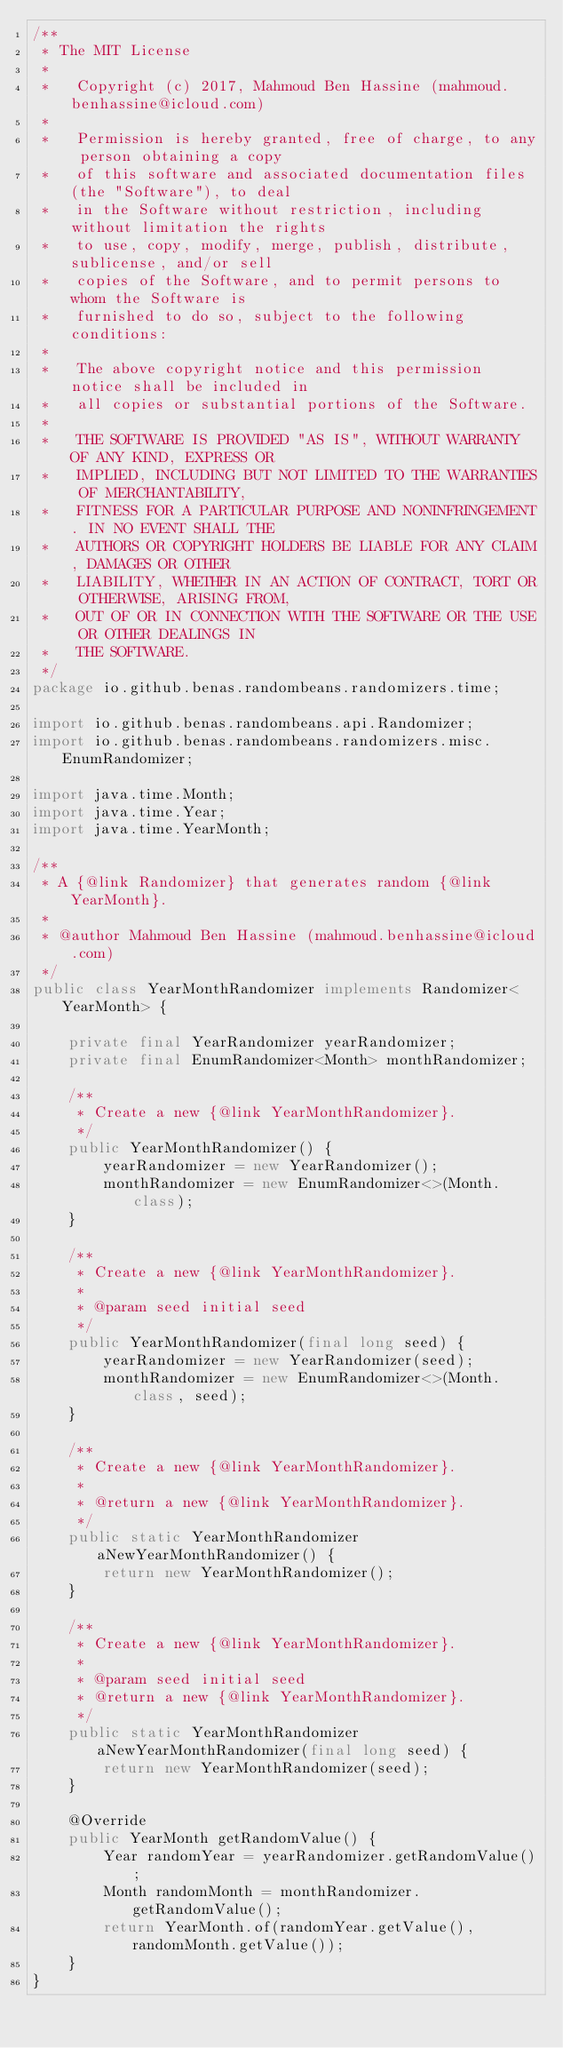Convert code to text. <code><loc_0><loc_0><loc_500><loc_500><_Java_>/**
 * The MIT License
 *
 *   Copyright (c) 2017, Mahmoud Ben Hassine (mahmoud.benhassine@icloud.com)
 *
 *   Permission is hereby granted, free of charge, to any person obtaining a copy
 *   of this software and associated documentation files (the "Software"), to deal
 *   in the Software without restriction, including without limitation the rights
 *   to use, copy, modify, merge, publish, distribute, sublicense, and/or sell
 *   copies of the Software, and to permit persons to whom the Software is
 *   furnished to do so, subject to the following conditions:
 *
 *   The above copyright notice and this permission notice shall be included in
 *   all copies or substantial portions of the Software.
 *
 *   THE SOFTWARE IS PROVIDED "AS IS", WITHOUT WARRANTY OF ANY KIND, EXPRESS OR
 *   IMPLIED, INCLUDING BUT NOT LIMITED TO THE WARRANTIES OF MERCHANTABILITY,
 *   FITNESS FOR A PARTICULAR PURPOSE AND NONINFRINGEMENT. IN NO EVENT SHALL THE
 *   AUTHORS OR COPYRIGHT HOLDERS BE LIABLE FOR ANY CLAIM, DAMAGES OR OTHER
 *   LIABILITY, WHETHER IN AN ACTION OF CONTRACT, TORT OR OTHERWISE, ARISING FROM,
 *   OUT OF OR IN CONNECTION WITH THE SOFTWARE OR THE USE OR OTHER DEALINGS IN
 *   THE SOFTWARE.
 */
package io.github.benas.randombeans.randomizers.time;

import io.github.benas.randombeans.api.Randomizer;
import io.github.benas.randombeans.randomizers.misc.EnumRandomizer;

import java.time.Month;
import java.time.Year;
import java.time.YearMonth;

/**
 * A {@link Randomizer} that generates random {@link YearMonth}.
 *
 * @author Mahmoud Ben Hassine (mahmoud.benhassine@icloud.com)
 */
public class YearMonthRandomizer implements Randomizer<YearMonth> {

    private final YearRandomizer yearRandomizer;
    private final EnumRandomizer<Month> monthRandomizer;

    /**
     * Create a new {@link YearMonthRandomizer}.
     */
    public YearMonthRandomizer() {
        yearRandomizer = new YearRandomizer();
        monthRandomizer = new EnumRandomizer<>(Month.class);
    }

    /**
     * Create a new {@link YearMonthRandomizer}.
     *
     * @param seed initial seed
     */
    public YearMonthRandomizer(final long seed) {
        yearRandomizer = new YearRandomizer(seed);
        monthRandomizer = new EnumRandomizer<>(Month.class, seed);
    }

    /**
     * Create a new {@link YearMonthRandomizer}.
     *
     * @return a new {@link YearMonthRandomizer}.
     */
    public static YearMonthRandomizer aNewYearMonthRandomizer() {
        return new YearMonthRandomizer();
    }

    /**
     * Create a new {@link YearMonthRandomizer}.
     *
     * @param seed initial seed
     * @return a new {@link YearMonthRandomizer}.
     */
    public static YearMonthRandomizer aNewYearMonthRandomizer(final long seed) {
        return new YearMonthRandomizer(seed);
    }

    @Override
    public YearMonth getRandomValue() {
        Year randomYear = yearRandomizer.getRandomValue();
        Month randomMonth = monthRandomizer.getRandomValue();
        return YearMonth.of(randomYear.getValue(), randomMonth.getValue());
    }
}
</code> 